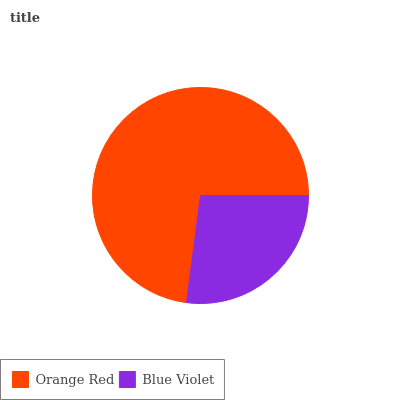Is Blue Violet the minimum?
Answer yes or no. Yes. Is Orange Red the maximum?
Answer yes or no. Yes. Is Blue Violet the maximum?
Answer yes or no. No. Is Orange Red greater than Blue Violet?
Answer yes or no. Yes. Is Blue Violet less than Orange Red?
Answer yes or no. Yes. Is Blue Violet greater than Orange Red?
Answer yes or no. No. Is Orange Red less than Blue Violet?
Answer yes or no. No. Is Orange Red the high median?
Answer yes or no. Yes. Is Blue Violet the low median?
Answer yes or no. Yes. Is Blue Violet the high median?
Answer yes or no. No. Is Orange Red the low median?
Answer yes or no. No. 